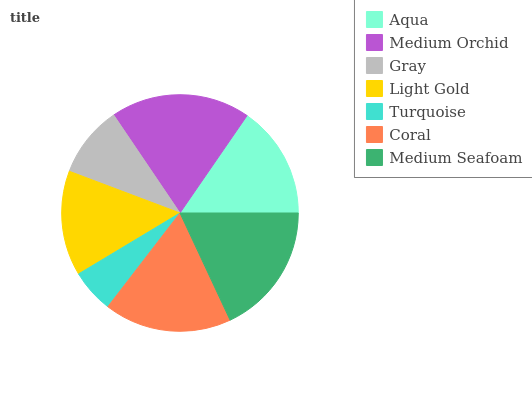Is Turquoise the minimum?
Answer yes or no. Yes. Is Medium Orchid the maximum?
Answer yes or no. Yes. Is Gray the minimum?
Answer yes or no. No. Is Gray the maximum?
Answer yes or no. No. Is Medium Orchid greater than Gray?
Answer yes or no. Yes. Is Gray less than Medium Orchid?
Answer yes or no. Yes. Is Gray greater than Medium Orchid?
Answer yes or no. No. Is Medium Orchid less than Gray?
Answer yes or no. No. Is Aqua the high median?
Answer yes or no. Yes. Is Aqua the low median?
Answer yes or no. Yes. Is Coral the high median?
Answer yes or no. No. Is Gray the low median?
Answer yes or no. No. 